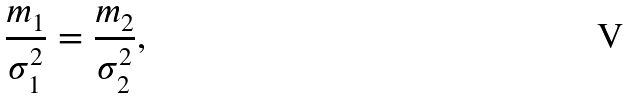Convert formula to latex. <formula><loc_0><loc_0><loc_500><loc_500>\frac { m _ { 1 } } { \sigma ^ { 2 } _ { 1 } } = \frac { m _ { 2 } } { \sigma ^ { 2 } _ { 2 } } ,</formula> 